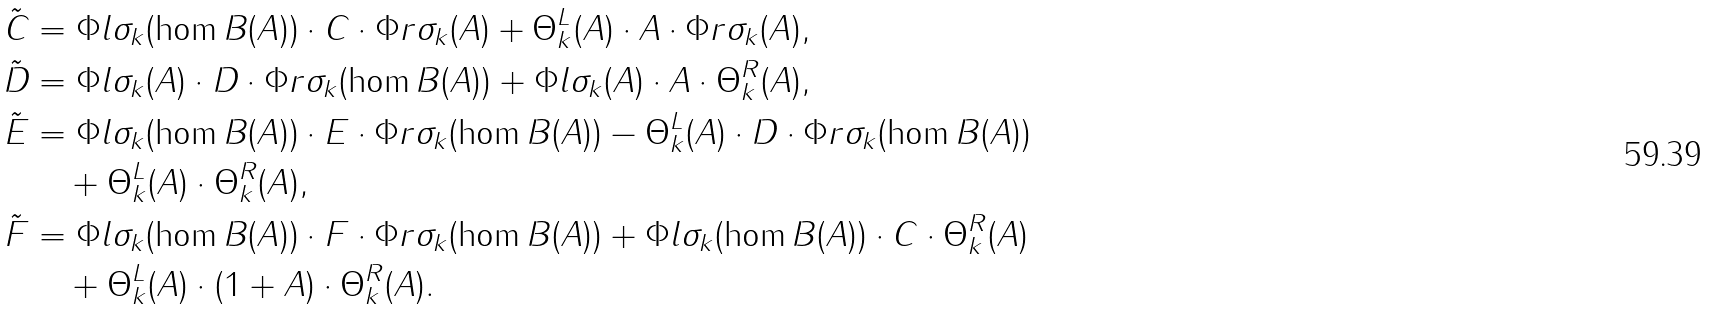Convert formula to latex. <formula><loc_0><loc_0><loc_500><loc_500>\tilde { C } & = \Phi l { \sigma _ { k } } ( \hom { B } ( A ) ) \cdot C \cdot \Phi r { \sigma _ { k } } ( A ) + \Theta ^ { L } _ { k } ( A ) \cdot A \cdot \Phi r { \sigma _ { k } } ( A ) , \\ \tilde { D } & = \Phi l { \sigma _ { k } } ( A ) \cdot D \cdot \Phi r { \sigma _ { k } } ( \hom { B } ( A ) ) + \Phi l { \sigma _ { k } } ( A ) \cdot A \cdot \Theta ^ { R } _ { k } ( A ) , \\ \tilde { E } & = \Phi l { \sigma _ { k } } ( \hom { B } ( A ) ) \cdot E \cdot \Phi r { \sigma _ { k } } ( \hom { B } ( A ) ) - \Theta ^ { L } _ { k } ( A ) \cdot D \cdot \Phi r { \sigma _ { k } } ( \hom { B } ( A ) ) \\ & \quad + \Theta ^ { L } _ { k } ( A ) \cdot \Theta ^ { R } _ { k } ( A ) , \\ \tilde { F } & = \Phi l { \sigma _ { k } } ( \hom { B } ( A ) ) \cdot F \cdot \Phi r { \sigma _ { k } } ( \hom { B } ( A ) ) + \Phi l { \sigma _ { k } } ( \hom { B } ( A ) ) \cdot C \cdot \Theta ^ { R } _ { k } ( A ) \\ & \quad + \Theta ^ { L } _ { k } ( A ) \cdot ( 1 + A ) \cdot \Theta ^ { R } _ { k } ( A ) .</formula> 